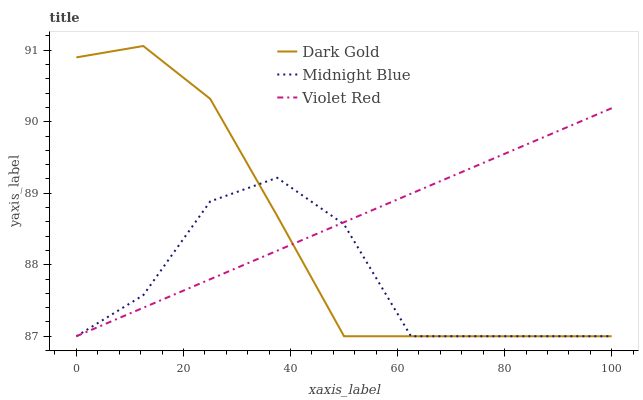Does Midnight Blue have the minimum area under the curve?
Answer yes or no. Yes. Does Violet Red have the maximum area under the curve?
Answer yes or no. Yes. Does Dark Gold have the minimum area under the curve?
Answer yes or no. No. Does Dark Gold have the maximum area under the curve?
Answer yes or no. No. Is Violet Red the smoothest?
Answer yes or no. Yes. Is Midnight Blue the roughest?
Answer yes or no. Yes. Is Dark Gold the smoothest?
Answer yes or no. No. Is Dark Gold the roughest?
Answer yes or no. No. Does Violet Red have the lowest value?
Answer yes or no. Yes. Does Dark Gold have the highest value?
Answer yes or no. Yes. Does Midnight Blue have the highest value?
Answer yes or no. No. Does Dark Gold intersect Violet Red?
Answer yes or no. Yes. Is Dark Gold less than Violet Red?
Answer yes or no. No. Is Dark Gold greater than Violet Red?
Answer yes or no. No. 